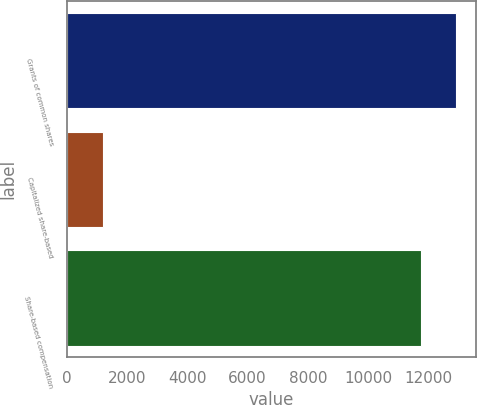Convert chart. <chart><loc_0><loc_0><loc_500><loc_500><bar_chart><fcel>Grants of common shares<fcel>Capitalized share-based<fcel>Share-based compensation<nl><fcel>12923.4<fcel>1188<fcel>11753<nl></chart> 